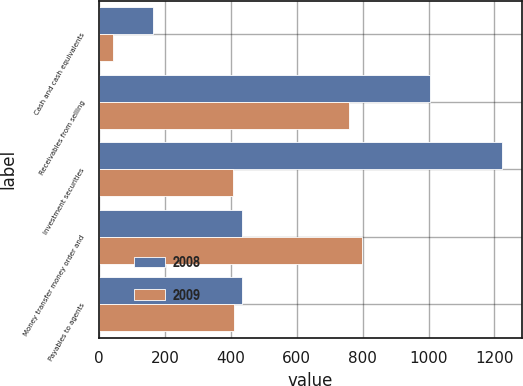Convert chart. <chart><loc_0><loc_0><loc_500><loc_500><stacked_bar_chart><ecel><fcel>Cash and cash equivalents<fcel>Receivables from selling<fcel>Investment securities<fcel>Money transfer money order and<fcel>Payables to agents<nl><fcel>2008<fcel>161.9<fcel>1004.4<fcel>1222.8<fcel>434.3<fcel>434.3<nl><fcel>2009<fcel>42.3<fcel>759.6<fcel>405.6<fcel>799.5<fcel>408<nl></chart> 